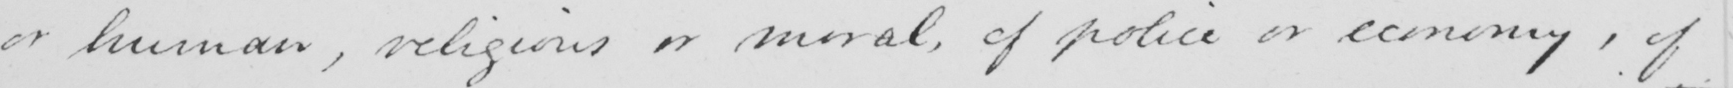Can you read and transcribe this handwriting? or human , religious or moral , of police or economy , of 